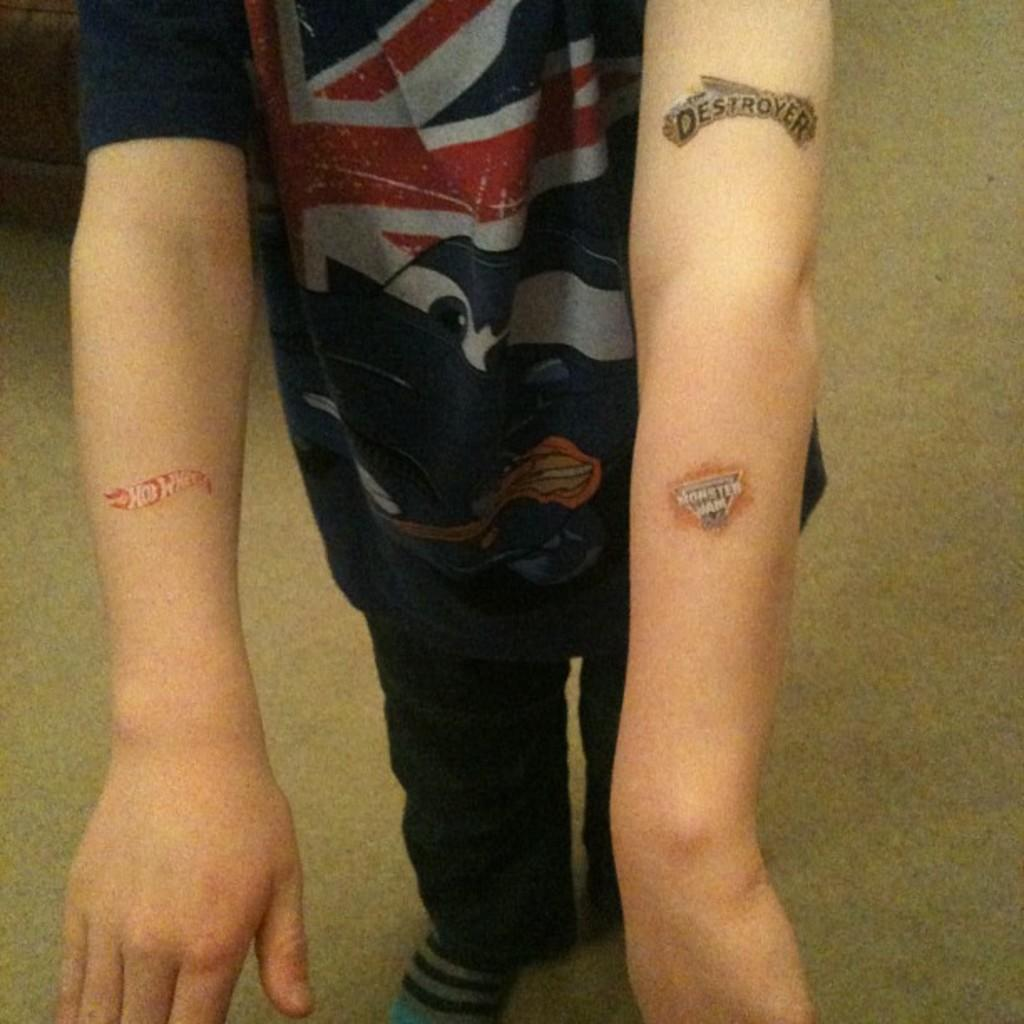<image>
Create a compact narrative representing the image presented. A person with three tattoos that read "Hot wheels" "Monster Jam" and Destroyer. 